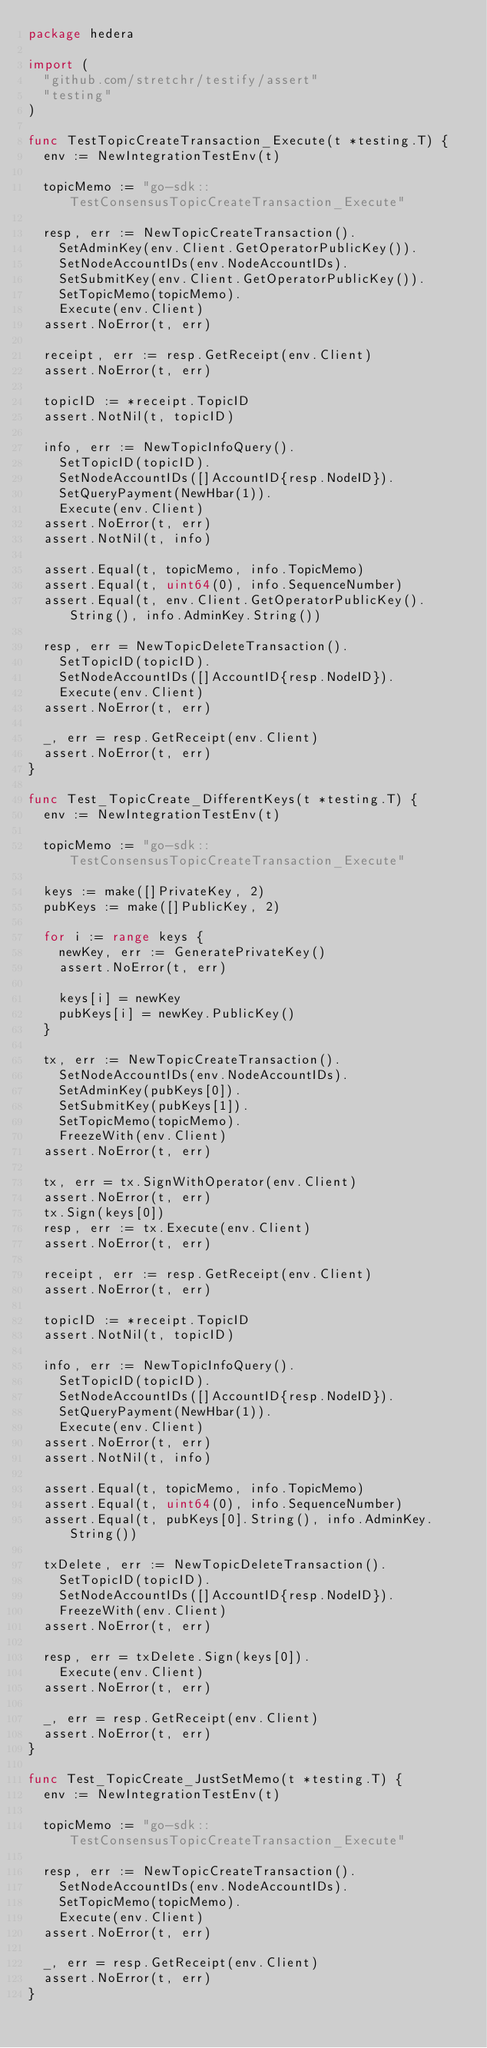Convert code to text. <code><loc_0><loc_0><loc_500><loc_500><_Go_>package hedera

import (
	"github.com/stretchr/testify/assert"
	"testing"
)

func TestTopicCreateTransaction_Execute(t *testing.T) {
	env := NewIntegrationTestEnv(t)

	topicMemo := "go-sdk::TestConsensusTopicCreateTransaction_Execute"

	resp, err := NewTopicCreateTransaction().
		SetAdminKey(env.Client.GetOperatorPublicKey()).
		SetNodeAccountIDs(env.NodeAccountIDs).
		SetSubmitKey(env.Client.GetOperatorPublicKey()).
		SetTopicMemo(topicMemo).
		Execute(env.Client)
	assert.NoError(t, err)

	receipt, err := resp.GetReceipt(env.Client)
	assert.NoError(t, err)

	topicID := *receipt.TopicID
	assert.NotNil(t, topicID)

	info, err := NewTopicInfoQuery().
		SetTopicID(topicID).
		SetNodeAccountIDs([]AccountID{resp.NodeID}).
		SetQueryPayment(NewHbar(1)).
		Execute(env.Client)
	assert.NoError(t, err)
	assert.NotNil(t, info)

	assert.Equal(t, topicMemo, info.TopicMemo)
	assert.Equal(t, uint64(0), info.SequenceNumber)
	assert.Equal(t, env.Client.GetOperatorPublicKey().String(), info.AdminKey.String())

	resp, err = NewTopicDeleteTransaction().
		SetTopicID(topicID).
		SetNodeAccountIDs([]AccountID{resp.NodeID}).
		Execute(env.Client)
	assert.NoError(t, err)

	_, err = resp.GetReceipt(env.Client)
	assert.NoError(t, err)
}

func Test_TopicCreate_DifferentKeys(t *testing.T) {
	env := NewIntegrationTestEnv(t)

	topicMemo := "go-sdk::TestConsensusTopicCreateTransaction_Execute"

	keys := make([]PrivateKey, 2)
	pubKeys := make([]PublicKey, 2)

	for i := range keys {
		newKey, err := GeneratePrivateKey()
		assert.NoError(t, err)

		keys[i] = newKey
		pubKeys[i] = newKey.PublicKey()
	}

	tx, err := NewTopicCreateTransaction().
		SetNodeAccountIDs(env.NodeAccountIDs).
		SetAdminKey(pubKeys[0]).
		SetSubmitKey(pubKeys[1]).
		SetTopicMemo(topicMemo).
		FreezeWith(env.Client)
	assert.NoError(t, err)

	tx, err = tx.SignWithOperator(env.Client)
	assert.NoError(t, err)
	tx.Sign(keys[0])
	resp, err := tx.Execute(env.Client)
	assert.NoError(t, err)

	receipt, err := resp.GetReceipt(env.Client)
	assert.NoError(t, err)

	topicID := *receipt.TopicID
	assert.NotNil(t, topicID)

	info, err := NewTopicInfoQuery().
		SetTopicID(topicID).
		SetNodeAccountIDs([]AccountID{resp.NodeID}).
		SetQueryPayment(NewHbar(1)).
		Execute(env.Client)
	assert.NoError(t, err)
	assert.NotNil(t, info)

	assert.Equal(t, topicMemo, info.TopicMemo)
	assert.Equal(t, uint64(0), info.SequenceNumber)
	assert.Equal(t, pubKeys[0].String(), info.AdminKey.String())

	txDelete, err := NewTopicDeleteTransaction().
		SetTopicID(topicID).
		SetNodeAccountIDs([]AccountID{resp.NodeID}).
		FreezeWith(env.Client)
	assert.NoError(t, err)

	resp, err = txDelete.Sign(keys[0]).
		Execute(env.Client)
	assert.NoError(t, err)

	_, err = resp.GetReceipt(env.Client)
	assert.NoError(t, err)
}

func Test_TopicCreate_JustSetMemo(t *testing.T) {
	env := NewIntegrationTestEnv(t)

	topicMemo := "go-sdk::TestConsensusTopicCreateTransaction_Execute"

	resp, err := NewTopicCreateTransaction().
		SetNodeAccountIDs(env.NodeAccountIDs).
		SetTopicMemo(topicMemo).
		Execute(env.Client)
	assert.NoError(t, err)

	_, err = resp.GetReceipt(env.Client)
	assert.NoError(t, err)
}
</code> 